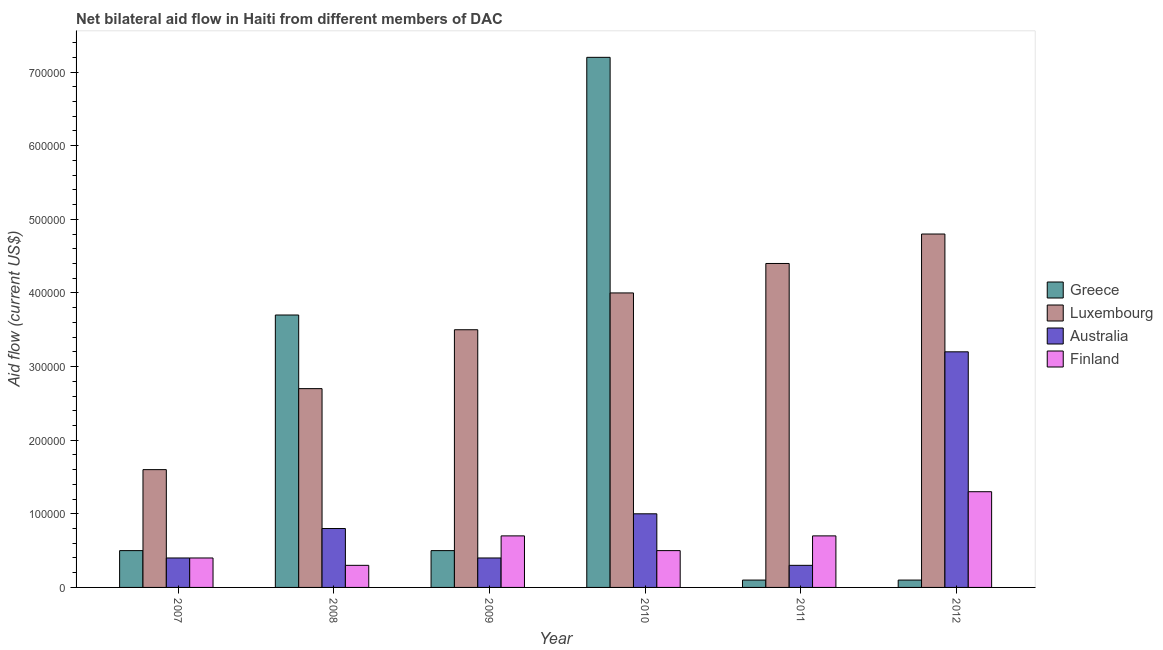How many different coloured bars are there?
Make the answer very short. 4. Are the number of bars per tick equal to the number of legend labels?
Offer a very short reply. Yes. Are the number of bars on each tick of the X-axis equal?
Your answer should be very brief. Yes. How many bars are there on the 3rd tick from the left?
Offer a very short reply. 4. How many bars are there on the 2nd tick from the right?
Provide a short and direct response. 4. What is the amount of aid given by greece in 2009?
Provide a short and direct response. 5.00e+04. Across all years, what is the maximum amount of aid given by greece?
Give a very brief answer. 7.20e+05. Across all years, what is the minimum amount of aid given by luxembourg?
Your response must be concise. 1.60e+05. In which year was the amount of aid given by australia maximum?
Your answer should be very brief. 2012. In which year was the amount of aid given by finland minimum?
Your response must be concise. 2008. What is the total amount of aid given by greece in the graph?
Keep it short and to the point. 1.21e+06. What is the difference between the amount of aid given by greece in 2007 and that in 2008?
Your answer should be compact. -3.20e+05. What is the difference between the amount of aid given by luxembourg in 2012 and the amount of aid given by greece in 2011?
Provide a succinct answer. 4.00e+04. What is the average amount of aid given by finland per year?
Your response must be concise. 6.50e+04. In how many years, is the amount of aid given by australia greater than 700000 US$?
Keep it short and to the point. 0. What is the difference between the highest and the lowest amount of aid given by greece?
Make the answer very short. 7.10e+05. In how many years, is the amount of aid given by luxembourg greater than the average amount of aid given by luxembourg taken over all years?
Offer a very short reply. 3. What does the 1st bar from the left in 2010 represents?
Offer a very short reply. Greece. What does the 3rd bar from the right in 2012 represents?
Ensure brevity in your answer.  Luxembourg. How many years are there in the graph?
Offer a very short reply. 6. What is the difference between two consecutive major ticks on the Y-axis?
Make the answer very short. 1.00e+05. Are the values on the major ticks of Y-axis written in scientific E-notation?
Offer a terse response. No. Does the graph contain grids?
Provide a short and direct response. No. How many legend labels are there?
Make the answer very short. 4. How are the legend labels stacked?
Ensure brevity in your answer.  Vertical. What is the title of the graph?
Offer a very short reply. Net bilateral aid flow in Haiti from different members of DAC. Does "European Union" appear as one of the legend labels in the graph?
Your answer should be very brief. No. What is the label or title of the X-axis?
Give a very brief answer. Year. What is the Aid flow (current US$) of Greece in 2007?
Offer a terse response. 5.00e+04. What is the Aid flow (current US$) of Australia in 2007?
Provide a succinct answer. 4.00e+04. What is the Aid flow (current US$) in Finland in 2007?
Ensure brevity in your answer.  4.00e+04. What is the Aid flow (current US$) of Greece in 2008?
Your answer should be very brief. 3.70e+05. What is the Aid flow (current US$) of Australia in 2008?
Your answer should be very brief. 8.00e+04. What is the Aid flow (current US$) in Greece in 2010?
Provide a succinct answer. 7.20e+05. What is the Aid flow (current US$) of Luxembourg in 2010?
Offer a very short reply. 4.00e+05. What is the Aid flow (current US$) in Australia in 2010?
Your answer should be very brief. 1.00e+05. What is the Aid flow (current US$) in Greece in 2011?
Give a very brief answer. 10000. What is the Aid flow (current US$) of Greece in 2012?
Ensure brevity in your answer.  10000. What is the Aid flow (current US$) in Australia in 2012?
Your answer should be compact. 3.20e+05. What is the Aid flow (current US$) in Finland in 2012?
Keep it short and to the point. 1.30e+05. Across all years, what is the maximum Aid flow (current US$) of Greece?
Your answer should be very brief. 7.20e+05. Across all years, what is the maximum Aid flow (current US$) of Luxembourg?
Give a very brief answer. 4.80e+05. What is the total Aid flow (current US$) in Greece in the graph?
Provide a short and direct response. 1.21e+06. What is the total Aid flow (current US$) of Luxembourg in the graph?
Offer a terse response. 2.10e+06. What is the total Aid flow (current US$) of Australia in the graph?
Give a very brief answer. 6.10e+05. What is the difference between the Aid flow (current US$) of Greece in 2007 and that in 2008?
Provide a short and direct response. -3.20e+05. What is the difference between the Aid flow (current US$) in Australia in 2007 and that in 2008?
Your answer should be compact. -4.00e+04. What is the difference between the Aid flow (current US$) in Finland in 2007 and that in 2008?
Ensure brevity in your answer.  10000. What is the difference between the Aid flow (current US$) of Australia in 2007 and that in 2009?
Make the answer very short. 0. What is the difference between the Aid flow (current US$) in Greece in 2007 and that in 2010?
Your answer should be compact. -6.70e+05. What is the difference between the Aid flow (current US$) in Finland in 2007 and that in 2010?
Give a very brief answer. -10000. What is the difference between the Aid flow (current US$) of Greece in 2007 and that in 2011?
Keep it short and to the point. 4.00e+04. What is the difference between the Aid flow (current US$) in Luxembourg in 2007 and that in 2011?
Provide a succinct answer. -2.80e+05. What is the difference between the Aid flow (current US$) in Luxembourg in 2007 and that in 2012?
Your answer should be compact. -3.20e+05. What is the difference between the Aid flow (current US$) of Australia in 2007 and that in 2012?
Make the answer very short. -2.80e+05. What is the difference between the Aid flow (current US$) of Finland in 2007 and that in 2012?
Offer a very short reply. -9.00e+04. What is the difference between the Aid flow (current US$) of Greece in 2008 and that in 2009?
Give a very brief answer. 3.20e+05. What is the difference between the Aid flow (current US$) of Australia in 2008 and that in 2009?
Your answer should be very brief. 4.00e+04. What is the difference between the Aid flow (current US$) in Greece in 2008 and that in 2010?
Offer a terse response. -3.50e+05. What is the difference between the Aid flow (current US$) of Greece in 2008 and that in 2011?
Provide a succinct answer. 3.60e+05. What is the difference between the Aid flow (current US$) of Australia in 2008 and that in 2011?
Ensure brevity in your answer.  5.00e+04. What is the difference between the Aid flow (current US$) of Finland in 2008 and that in 2011?
Your response must be concise. -4.00e+04. What is the difference between the Aid flow (current US$) of Finland in 2008 and that in 2012?
Provide a short and direct response. -1.00e+05. What is the difference between the Aid flow (current US$) of Greece in 2009 and that in 2010?
Ensure brevity in your answer.  -6.70e+05. What is the difference between the Aid flow (current US$) of Luxembourg in 2009 and that in 2011?
Your response must be concise. -9.00e+04. What is the difference between the Aid flow (current US$) of Finland in 2009 and that in 2011?
Provide a short and direct response. 0. What is the difference between the Aid flow (current US$) in Greece in 2009 and that in 2012?
Ensure brevity in your answer.  4.00e+04. What is the difference between the Aid flow (current US$) of Luxembourg in 2009 and that in 2012?
Offer a very short reply. -1.30e+05. What is the difference between the Aid flow (current US$) in Australia in 2009 and that in 2012?
Offer a terse response. -2.80e+05. What is the difference between the Aid flow (current US$) of Finland in 2009 and that in 2012?
Give a very brief answer. -6.00e+04. What is the difference between the Aid flow (current US$) in Greece in 2010 and that in 2011?
Offer a very short reply. 7.10e+05. What is the difference between the Aid flow (current US$) of Finland in 2010 and that in 2011?
Provide a succinct answer. -2.00e+04. What is the difference between the Aid flow (current US$) of Greece in 2010 and that in 2012?
Offer a very short reply. 7.10e+05. What is the difference between the Aid flow (current US$) in Luxembourg in 2010 and that in 2012?
Offer a terse response. -8.00e+04. What is the difference between the Aid flow (current US$) of Australia in 2010 and that in 2012?
Provide a succinct answer. -2.20e+05. What is the difference between the Aid flow (current US$) of Luxembourg in 2007 and the Aid flow (current US$) of Australia in 2008?
Offer a terse response. 8.00e+04. What is the difference between the Aid flow (current US$) in Australia in 2007 and the Aid flow (current US$) in Finland in 2008?
Give a very brief answer. 10000. What is the difference between the Aid flow (current US$) in Australia in 2007 and the Aid flow (current US$) in Finland in 2009?
Your answer should be very brief. -3.00e+04. What is the difference between the Aid flow (current US$) of Greece in 2007 and the Aid flow (current US$) of Luxembourg in 2010?
Ensure brevity in your answer.  -3.50e+05. What is the difference between the Aid flow (current US$) of Luxembourg in 2007 and the Aid flow (current US$) of Finland in 2010?
Offer a terse response. 1.10e+05. What is the difference between the Aid flow (current US$) in Australia in 2007 and the Aid flow (current US$) in Finland in 2010?
Your answer should be compact. -10000. What is the difference between the Aid flow (current US$) in Greece in 2007 and the Aid flow (current US$) in Luxembourg in 2011?
Your answer should be compact. -3.90e+05. What is the difference between the Aid flow (current US$) of Greece in 2007 and the Aid flow (current US$) of Australia in 2011?
Give a very brief answer. 2.00e+04. What is the difference between the Aid flow (current US$) in Australia in 2007 and the Aid flow (current US$) in Finland in 2011?
Your answer should be very brief. -3.00e+04. What is the difference between the Aid flow (current US$) of Greece in 2007 and the Aid flow (current US$) of Luxembourg in 2012?
Give a very brief answer. -4.30e+05. What is the difference between the Aid flow (current US$) of Luxembourg in 2007 and the Aid flow (current US$) of Finland in 2012?
Your answer should be very brief. 3.00e+04. What is the difference between the Aid flow (current US$) of Australia in 2007 and the Aid flow (current US$) of Finland in 2012?
Give a very brief answer. -9.00e+04. What is the difference between the Aid flow (current US$) in Greece in 2008 and the Aid flow (current US$) in Luxembourg in 2009?
Your answer should be compact. 2.00e+04. What is the difference between the Aid flow (current US$) of Greece in 2008 and the Aid flow (current US$) of Australia in 2009?
Give a very brief answer. 3.30e+05. What is the difference between the Aid flow (current US$) of Greece in 2008 and the Aid flow (current US$) of Finland in 2009?
Provide a short and direct response. 3.00e+05. What is the difference between the Aid flow (current US$) in Luxembourg in 2008 and the Aid flow (current US$) in Australia in 2009?
Your response must be concise. 2.30e+05. What is the difference between the Aid flow (current US$) of Luxembourg in 2008 and the Aid flow (current US$) of Finland in 2009?
Your answer should be compact. 2.00e+05. What is the difference between the Aid flow (current US$) in Australia in 2008 and the Aid flow (current US$) in Finland in 2009?
Keep it short and to the point. 10000. What is the difference between the Aid flow (current US$) of Greece in 2008 and the Aid flow (current US$) of Luxembourg in 2010?
Keep it short and to the point. -3.00e+04. What is the difference between the Aid flow (current US$) of Luxembourg in 2008 and the Aid flow (current US$) of Australia in 2010?
Provide a short and direct response. 1.70e+05. What is the difference between the Aid flow (current US$) in Luxembourg in 2008 and the Aid flow (current US$) in Finland in 2010?
Your response must be concise. 2.20e+05. What is the difference between the Aid flow (current US$) in Australia in 2008 and the Aid flow (current US$) in Finland in 2010?
Your response must be concise. 3.00e+04. What is the difference between the Aid flow (current US$) in Greece in 2008 and the Aid flow (current US$) in Luxembourg in 2011?
Offer a terse response. -7.00e+04. What is the difference between the Aid flow (current US$) in Luxembourg in 2008 and the Aid flow (current US$) in Finland in 2011?
Your response must be concise. 2.00e+05. What is the difference between the Aid flow (current US$) in Australia in 2008 and the Aid flow (current US$) in Finland in 2011?
Offer a terse response. 10000. What is the difference between the Aid flow (current US$) of Luxembourg in 2008 and the Aid flow (current US$) of Finland in 2012?
Your response must be concise. 1.40e+05. What is the difference between the Aid flow (current US$) in Greece in 2009 and the Aid flow (current US$) in Luxembourg in 2010?
Keep it short and to the point. -3.50e+05. What is the difference between the Aid flow (current US$) of Greece in 2009 and the Aid flow (current US$) of Australia in 2010?
Make the answer very short. -5.00e+04. What is the difference between the Aid flow (current US$) of Luxembourg in 2009 and the Aid flow (current US$) of Australia in 2010?
Offer a very short reply. 2.50e+05. What is the difference between the Aid flow (current US$) of Greece in 2009 and the Aid flow (current US$) of Luxembourg in 2011?
Your answer should be compact. -3.90e+05. What is the difference between the Aid flow (current US$) in Luxembourg in 2009 and the Aid flow (current US$) in Australia in 2011?
Provide a succinct answer. 3.20e+05. What is the difference between the Aid flow (current US$) in Australia in 2009 and the Aid flow (current US$) in Finland in 2011?
Offer a terse response. -3.00e+04. What is the difference between the Aid flow (current US$) of Greece in 2009 and the Aid flow (current US$) of Luxembourg in 2012?
Your answer should be very brief. -4.30e+05. What is the difference between the Aid flow (current US$) in Luxembourg in 2009 and the Aid flow (current US$) in Australia in 2012?
Your response must be concise. 3.00e+04. What is the difference between the Aid flow (current US$) of Greece in 2010 and the Aid flow (current US$) of Australia in 2011?
Provide a succinct answer. 6.90e+05. What is the difference between the Aid flow (current US$) of Greece in 2010 and the Aid flow (current US$) of Finland in 2011?
Your answer should be compact. 6.50e+05. What is the difference between the Aid flow (current US$) of Luxembourg in 2010 and the Aid flow (current US$) of Australia in 2011?
Provide a short and direct response. 3.70e+05. What is the difference between the Aid flow (current US$) of Luxembourg in 2010 and the Aid flow (current US$) of Finland in 2011?
Provide a succinct answer. 3.30e+05. What is the difference between the Aid flow (current US$) of Australia in 2010 and the Aid flow (current US$) of Finland in 2011?
Provide a short and direct response. 3.00e+04. What is the difference between the Aid flow (current US$) in Greece in 2010 and the Aid flow (current US$) in Finland in 2012?
Make the answer very short. 5.90e+05. What is the difference between the Aid flow (current US$) of Luxembourg in 2010 and the Aid flow (current US$) of Australia in 2012?
Make the answer very short. 8.00e+04. What is the difference between the Aid flow (current US$) in Greece in 2011 and the Aid flow (current US$) in Luxembourg in 2012?
Offer a very short reply. -4.70e+05. What is the difference between the Aid flow (current US$) in Greece in 2011 and the Aid flow (current US$) in Australia in 2012?
Your response must be concise. -3.10e+05. What is the difference between the Aid flow (current US$) of Luxembourg in 2011 and the Aid flow (current US$) of Finland in 2012?
Keep it short and to the point. 3.10e+05. What is the average Aid flow (current US$) in Greece per year?
Keep it short and to the point. 2.02e+05. What is the average Aid flow (current US$) in Australia per year?
Provide a succinct answer. 1.02e+05. What is the average Aid flow (current US$) in Finland per year?
Ensure brevity in your answer.  6.50e+04. In the year 2007, what is the difference between the Aid flow (current US$) of Greece and Aid flow (current US$) of Luxembourg?
Provide a succinct answer. -1.10e+05. In the year 2007, what is the difference between the Aid flow (current US$) in Luxembourg and Aid flow (current US$) in Finland?
Provide a short and direct response. 1.20e+05. In the year 2007, what is the difference between the Aid flow (current US$) of Australia and Aid flow (current US$) of Finland?
Provide a short and direct response. 0. In the year 2008, what is the difference between the Aid flow (current US$) of Greece and Aid flow (current US$) of Luxembourg?
Make the answer very short. 1.00e+05. In the year 2008, what is the difference between the Aid flow (current US$) in Greece and Aid flow (current US$) in Australia?
Make the answer very short. 2.90e+05. In the year 2008, what is the difference between the Aid flow (current US$) in Greece and Aid flow (current US$) in Finland?
Your response must be concise. 3.40e+05. In the year 2008, what is the difference between the Aid flow (current US$) in Luxembourg and Aid flow (current US$) in Finland?
Offer a very short reply. 2.40e+05. In the year 2008, what is the difference between the Aid flow (current US$) of Australia and Aid flow (current US$) of Finland?
Offer a very short reply. 5.00e+04. In the year 2009, what is the difference between the Aid flow (current US$) of Greece and Aid flow (current US$) of Luxembourg?
Offer a terse response. -3.00e+05. In the year 2009, what is the difference between the Aid flow (current US$) of Greece and Aid flow (current US$) of Australia?
Give a very brief answer. 10000. In the year 2009, what is the difference between the Aid flow (current US$) in Greece and Aid flow (current US$) in Finland?
Your response must be concise. -2.00e+04. In the year 2009, what is the difference between the Aid flow (current US$) of Luxembourg and Aid flow (current US$) of Finland?
Offer a very short reply. 2.80e+05. In the year 2010, what is the difference between the Aid flow (current US$) in Greece and Aid flow (current US$) in Australia?
Provide a short and direct response. 6.20e+05. In the year 2010, what is the difference between the Aid flow (current US$) of Greece and Aid flow (current US$) of Finland?
Keep it short and to the point. 6.70e+05. In the year 2010, what is the difference between the Aid flow (current US$) in Luxembourg and Aid flow (current US$) in Finland?
Provide a succinct answer. 3.50e+05. In the year 2010, what is the difference between the Aid flow (current US$) in Australia and Aid flow (current US$) in Finland?
Your answer should be compact. 5.00e+04. In the year 2011, what is the difference between the Aid flow (current US$) in Greece and Aid flow (current US$) in Luxembourg?
Your answer should be compact. -4.30e+05. In the year 2011, what is the difference between the Aid flow (current US$) of Greece and Aid flow (current US$) of Finland?
Provide a short and direct response. -6.00e+04. In the year 2011, what is the difference between the Aid flow (current US$) of Luxembourg and Aid flow (current US$) of Finland?
Offer a terse response. 3.70e+05. In the year 2012, what is the difference between the Aid flow (current US$) of Greece and Aid flow (current US$) of Luxembourg?
Your response must be concise. -4.70e+05. In the year 2012, what is the difference between the Aid flow (current US$) of Greece and Aid flow (current US$) of Australia?
Offer a very short reply. -3.10e+05. In the year 2012, what is the difference between the Aid flow (current US$) of Luxembourg and Aid flow (current US$) of Australia?
Give a very brief answer. 1.60e+05. In the year 2012, what is the difference between the Aid flow (current US$) of Luxembourg and Aid flow (current US$) of Finland?
Your response must be concise. 3.50e+05. What is the ratio of the Aid flow (current US$) of Greece in 2007 to that in 2008?
Offer a terse response. 0.14. What is the ratio of the Aid flow (current US$) in Luxembourg in 2007 to that in 2008?
Keep it short and to the point. 0.59. What is the ratio of the Aid flow (current US$) in Finland in 2007 to that in 2008?
Your response must be concise. 1.33. What is the ratio of the Aid flow (current US$) in Luxembourg in 2007 to that in 2009?
Provide a succinct answer. 0.46. What is the ratio of the Aid flow (current US$) of Australia in 2007 to that in 2009?
Keep it short and to the point. 1. What is the ratio of the Aid flow (current US$) of Finland in 2007 to that in 2009?
Ensure brevity in your answer.  0.57. What is the ratio of the Aid flow (current US$) in Greece in 2007 to that in 2010?
Offer a terse response. 0.07. What is the ratio of the Aid flow (current US$) of Luxembourg in 2007 to that in 2010?
Offer a very short reply. 0.4. What is the ratio of the Aid flow (current US$) in Australia in 2007 to that in 2010?
Keep it short and to the point. 0.4. What is the ratio of the Aid flow (current US$) in Greece in 2007 to that in 2011?
Offer a very short reply. 5. What is the ratio of the Aid flow (current US$) of Luxembourg in 2007 to that in 2011?
Make the answer very short. 0.36. What is the ratio of the Aid flow (current US$) of Australia in 2007 to that in 2012?
Provide a succinct answer. 0.12. What is the ratio of the Aid flow (current US$) of Finland in 2007 to that in 2012?
Offer a very short reply. 0.31. What is the ratio of the Aid flow (current US$) of Luxembourg in 2008 to that in 2009?
Give a very brief answer. 0.77. What is the ratio of the Aid flow (current US$) of Australia in 2008 to that in 2009?
Your answer should be very brief. 2. What is the ratio of the Aid flow (current US$) of Finland in 2008 to that in 2009?
Your answer should be compact. 0.43. What is the ratio of the Aid flow (current US$) of Greece in 2008 to that in 2010?
Your answer should be very brief. 0.51. What is the ratio of the Aid flow (current US$) in Luxembourg in 2008 to that in 2010?
Provide a short and direct response. 0.68. What is the ratio of the Aid flow (current US$) of Luxembourg in 2008 to that in 2011?
Make the answer very short. 0.61. What is the ratio of the Aid flow (current US$) in Australia in 2008 to that in 2011?
Your answer should be very brief. 2.67. What is the ratio of the Aid flow (current US$) in Finland in 2008 to that in 2011?
Keep it short and to the point. 0.43. What is the ratio of the Aid flow (current US$) in Greece in 2008 to that in 2012?
Your answer should be compact. 37. What is the ratio of the Aid flow (current US$) of Luxembourg in 2008 to that in 2012?
Provide a short and direct response. 0.56. What is the ratio of the Aid flow (current US$) in Australia in 2008 to that in 2012?
Give a very brief answer. 0.25. What is the ratio of the Aid flow (current US$) in Finland in 2008 to that in 2012?
Provide a succinct answer. 0.23. What is the ratio of the Aid flow (current US$) in Greece in 2009 to that in 2010?
Keep it short and to the point. 0.07. What is the ratio of the Aid flow (current US$) of Luxembourg in 2009 to that in 2010?
Make the answer very short. 0.88. What is the ratio of the Aid flow (current US$) of Luxembourg in 2009 to that in 2011?
Your response must be concise. 0.8. What is the ratio of the Aid flow (current US$) of Australia in 2009 to that in 2011?
Offer a very short reply. 1.33. What is the ratio of the Aid flow (current US$) of Luxembourg in 2009 to that in 2012?
Keep it short and to the point. 0.73. What is the ratio of the Aid flow (current US$) in Finland in 2009 to that in 2012?
Offer a very short reply. 0.54. What is the ratio of the Aid flow (current US$) of Greece in 2010 to that in 2011?
Offer a very short reply. 72. What is the ratio of the Aid flow (current US$) in Greece in 2010 to that in 2012?
Ensure brevity in your answer.  72. What is the ratio of the Aid flow (current US$) of Australia in 2010 to that in 2012?
Your response must be concise. 0.31. What is the ratio of the Aid flow (current US$) in Finland in 2010 to that in 2012?
Your response must be concise. 0.38. What is the ratio of the Aid flow (current US$) in Greece in 2011 to that in 2012?
Give a very brief answer. 1. What is the ratio of the Aid flow (current US$) in Australia in 2011 to that in 2012?
Keep it short and to the point. 0.09. What is the ratio of the Aid flow (current US$) of Finland in 2011 to that in 2012?
Offer a very short reply. 0.54. What is the difference between the highest and the second highest Aid flow (current US$) of Luxembourg?
Give a very brief answer. 4.00e+04. What is the difference between the highest and the second highest Aid flow (current US$) in Australia?
Provide a short and direct response. 2.20e+05. What is the difference between the highest and the lowest Aid flow (current US$) in Greece?
Your answer should be compact. 7.10e+05. What is the difference between the highest and the lowest Aid flow (current US$) of Luxembourg?
Provide a short and direct response. 3.20e+05. What is the difference between the highest and the lowest Aid flow (current US$) of Finland?
Ensure brevity in your answer.  1.00e+05. 